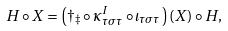<formula> <loc_0><loc_0><loc_500><loc_500>H \circ X = \left ( \dagger _ { \ddagger } \circ \kappa _ { \tau \sigma \tau } ^ { I } \circ \iota _ { \tau \sigma \tau } \right ) ( X ) \circ H ,</formula> 